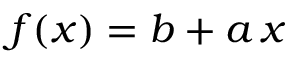<formula> <loc_0><loc_0><loc_500><loc_500>f ( x ) = b + a \, x</formula> 